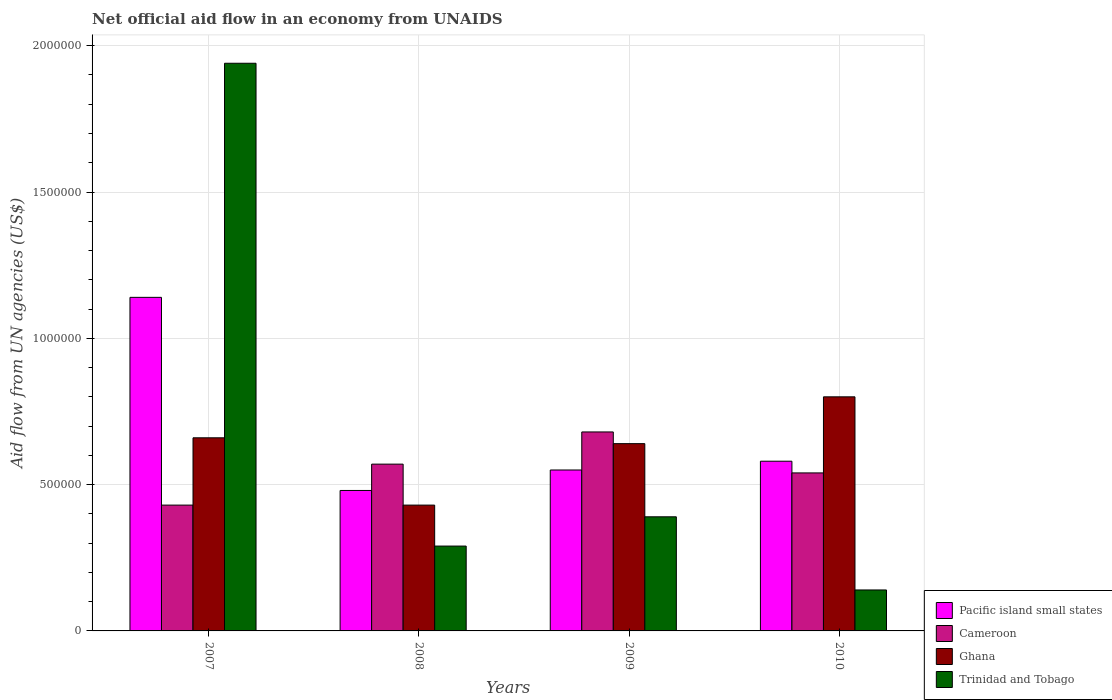How many groups of bars are there?
Your answer should be very brief. 4. Are the number of bars per tick equal to the number of legend labels?
Your response must be concise. Yes. What is the label of the 2nd group of bars from the left?
Provide a succinct answer. 2008. In how many cases, is the number of bars for a given year not equal to the number of legend labels?
Provide a short and direct response. 0. What is the net official aid flow in Ghana in 2007?
Your answer should be very brief. 6.60e+05. Across all years, what is the maximum net official aid flow in Pacific island small states?
Your answer should be very brief. 1.14e+06. Across all years, what is the minimum net official aid flow in Cameroon?
Offer a very short reply. 4.30e+05. In which year was the net official aid flow in Ghana minimum?
Your answer should be very brief. 2008. What is the total net official aid flow in Ghana in the graph?
Make the answer very short. 2.53e+06. What is the difference between the net official aid flow in Trinidad and Tobago in 2007 and that in 2009?
Offer a very short reply. 1.55e+06. What is the difference between the net official aid flow in Pacific island small states in 2007 and the net official aid flow in Trinidad and Tobago in 2009?
Give a very brief answer. 7.50e+05. What is the average net official aid flow in Cameroon per year?
Offer a terse response. 5.55e+05. In the year 2007, what is the difference between the net official aid flow in Cameroon and net official aid flow in Trinidad and Tobago?
Give a very brief answer. -1.51e+06. What is the ratio of the net official aid flow in Trinidad and Tobago in 2008 to that in 2010?
Make the answer very short. 2.07. Is the net official aid flow in Ghana in 2008 less than that in 2009?
Give a very brief answer. Yes. Is the difference between the net official aid flow in Cameroon in 2008 and 2010 greater than the difference between the net official aid flow in Trinidad and Tobago in 2008 and 2010?
Ensure brevity in your answer.  No. What is the difference between the highest and the second highest net official aid flow in Pacific island small states?
Make the answer very short. 5.60e+05. What is the difference between the highest and the lowest net official aid flow in Trinidad and Tobago?
Your answer should be compact. 1.80e+06. In how many years, is the net official aid flow in Pacific island small states greater than the average net official aid flow in Pacific island small states taken over all years?
Provide a succinct answer. 1. Is the sum of the net official aid flow in Pacific island small states in 2008 and 2010 greater than the maximum net official aid flow in Trinidad and Tobago across all years?
Offer a terse response. No. What does the 2nd bar from the left in 2007 represents?
Offer a terse response. Cameroon. What does the 4th bar from the right in 2010 represents?
Provide a short and direct response. Pacific island small states. Is it the case that in every year, the sum of the net official aid flow in Pacific island small states and net official aid flow in Ghana is greater than the net official aid flow in Cameroon?
Keep it short and to the point. Yes. Are all the bars in the graph horizontal?
Ensure brevity in your answer.  No. What is the difference between two consecutive major ticks on the Y-axis?
Your response must be concise. 5.00e+05. Where does the legend appear in the graph?
Offer a very short reply. Bottom right. How are the legend labels stacked?
Your response must be concise. Vertical. What is the title of the graph?
Provide a succinct answer. Net official aid flow in an economy from UNAIDS. What is the label or title of the X-axis?
Your response must be concise. Years. What is the label or title of the Y-axis?
Ensure brevity in your answer.  Aid flow from UN agencies (US$). What is the Aid flow from UN agencies (US$) of Pacific island small states in 2007?
Give a very brief answer. 1.14e+06. What is the Aid flow from UN agencies (US$) of Trinidad and Tobago in 2007?
Your answer should be compact. 1.94e+06. What is the Aid flow from UN agencies (US$) in Pacific island small states in 2008?
Offer a very short reply. 4.80e+05. What is the Aid flow from UN agencies (US$) in Cameroon in 2008?
Give a very brief answer. 5.70e+05. What is the Aid flow from UN agencies (US$) in Trinidad and Tobago in 2008?
Make the answer very short. 2.90e+05. What is the Aid flow from UN agencies (US$) in Pacific island small states in 2009?
Your response must be concise. 5.50e+05. What is the Aid flow from UN agencies (US$) of Cameroon in 2009?
Offer a terse response. 6.80e+05. What is the Aid flow from UN agencies (US$) of Ghana in 2009?
Provide a succinct answer. 6.40e+05. What is the Aid flow from UN agencies (US$) in Pacific island small states in 2010?
Make the answer very short. 5.80e+05. What is the Aid flow from UN agencies (US$) in Cameroon in 2010?
Provide a short and direct response. 5.40e+05. What is the Aid flow from UN agencies (US$) in Ghana in 2010?
Your response must be concise. 8.00e+05. What is the Aid flow from UN agencies (US$) in Trinidad and Tobago in 2010?
Ensure brevity in your answer.  1.40e+05. Across all years, what is the maximum Aid flow from UN agencies (US$) in Pacific island small states?
Give a very brief answer. 1.14e+06. Across all years, what is the maximum Aid flow from UN agencies (US$) of Cameroon?
Make the answer very short. 6.80e+05. Across all years, what is the maximum Aid flow from UN agencies (US$) in Ghana?
Ensure brevity in your answer.  8.00e+05. Across all years, what is the maximum Aid flow from UN agencies (US$) of Trinidad and Tobago?
Give a very brief answer. 1.94e+06. Across all years, what is the minimum Aid flow from UN agencies (US$) in Cameroon?
Offer a very short reply. 4.30e+05. What is the total Aid flow from UN agencies (US$) of Pacific island small states in the graph?
Provide a short and direct response. 2.75e+06. What is the total Aid flow from UN agencies (US$) in Cameroon in the graph?
Your answer should be compact. 2.22e+06. What is the total Aid flow from UN agencies (US$) in Ghana in the graph?
Your answer should be compact. 2.53e+06. What is the total Aid flow from UN agencies (US$) in Trinidad and Tobago in the graph?
Give a very brief answer. 2.76e+06. What is the difference between the Aid flow from UN agencies (US$) of Trinidad and Tobago in 2007 and that in 2008?
Offer a very short reply. 1.65e+06. What is the difference between the Aid flow from UN agencies (US$) in Pacific island small states in 2007 and that in 2009?
Offer a terse response. 5.90e+05. What is the difference between the Aid flow from UN agencies (US$) in Trinidad and Tobago in 2007 and that in 2009?
Your answer should be very brief. 1.55e+06. What is the difference between the Aid flow from UN agencies (US$) in Pacific island small states in 2007 and that in 2010?
Provide a succinct answer. 5.60e+05. What is the difference between the Aid flow from UN agencies (US$) in Trinidad and Tobago in 2007 and that in 2010?
Offer a terse response. 1.80e+06. What is the difference between the Aid flow from UN agencies (US$) in Pacific island small states in 2008 and that in 2009?
Your answer should be compact. -7.00e+04. What is the difference between the Aid flow from UN agencies (US$) of Ghana in 2008 and that in 2009?
Give a very brief answer. -2.10e+05. What is the difference between the Aid flow from UN agencies (US$) of Pacific island small states in 2008 and that in 2010?
Your answer should be very brief. -1.00e+05. What is the difference between the Aid flow from UN agencies (US$) of Ghana in 2008 and that in 2010?
Provide a succinct answer. -3.70e+05. What is the difference between the Aid flow from UN agencies (US$) of Trinidad and Tobago in 2008 and that in 2010?
Provide a short and direct response. 1.50e+05. What is the difference between the Aid flow from UN agencies (US$) in Pacific island small states in 2009 and that in 2010?
Give a very brief answer. -3.00e+04. What is the difference between the Aid flow from UN agencies (US$) in Cameroon in 2009 and that in 2010?
Provide a succinct answer. 1.40e+05. What is the difference between the Aid flow from UN agencies (US$) of Pacific island small states in 2007 and the Aid flow from UN agencies (US$) of Cameroon in 2008?
Provide a short and direct response. 5.70e+05. What is the difference between the Aid flow from UN agencies (US$) of Pacific island small states in 2007 and the Aid flow from UN agencies (US$) of Ghana in 2008?
Provide a succinct answer. 7.10e+05. What is the difference between the Aid flow from UN agencies (US$) in Pacific island small states in 2007 and the Aid flow from UN agencies (US$) in Trinidad and Tobago in 2008?
Your response must be concise. 8.50e+05. What is the difference between the Aid flow from UN agencies (US$) of Cameroon in 2007 and the Aid flow from UN agencies (US$) of Ghana in 2008?
Provide a succinct answer. 0. What is the difference between the Aid flow from UN agencies (US$) of Cameroon in 2007 and the Aid flow from UN agencies (US$) of Trinidad and Tobago in 2008?
Make the answer very short. 1.40e+05. What is the difference between the Aid flow from UN agencies (US$) in Ghana in 2007 and the Aid flow from UN agencies (US$) in Trinidad and Tobago in 2008?
Your answer should be very brief. 3.70e+05. What is the difference between the Aid flow from UN agencies (US$) in Pacific island small states in 2007 and the Aid flow from UN agencies (US$) in Cameroon in 2009?
Your response must be concise. 4.60e+05. What is the difference between the Aid flow from UN agencies (US$) of Pacific island small states in 2007 and the Aid flow from UN agencies (US$) of Ghana in 2009?
Your response must be concise. 5.00e+05. What is the difference between the Aid flow from UN agencies (US$) in Pacific island small states in 2007 and the Aid flow from UN agencies (US$) in Trinidad and Tobago in 2009?
Offer a very short reply. 7.50e+05. What is the difference between the Aid flow from UN agencies (US$) of Cameroon in 2007 and the Aid flow from UN agencies (US$) of Ghana in 2009?
Make the answer very short. -2.10e+05. What is the difference between the Aid flow from UN agencies (US$) in Ghana in 2007 and the Aid flow from UN agencies (US$) in Trinidad and Tobago in 2009?
Offer a very short reply. 2.70e+05. What is the difference between the Aid flow from UN agencies (US$) of Pacific island small states in 2007 and the Aid flow from UN agencies (US$) of Trinidad and Tobago in 2010?
Your answer should be very brief. 1.00e+06. What is the difference between the Aid flow from UN agencies (US$) in Cameroon in 2007 and the Aid flow from UN agencies (US$) in Ghana in 2010?
Your response must be concise. -3.70e+05. What is the difference between the Aid flow from UN agencies (US$) in Cameroon in 2007 and the Aid flow from UN agencies (US$) in Trinidad and Tobago in 2010?
Keep it short and to the point. 2.90e+05. What is the difference between the Aid flow from UN agencies (US$) of Ghana in 2007 and the Aid flow from UN agencies (US$) of Trinidad and Tobago in 2010?
Provide a short and direct response. 5.20e+05. What is the difference between the Aid flow from UN agencies (US$) of Pacific island small states in 2008 and the Aid flow from UN agencies (US$) of Cameroon in 2009?
Give a very brief answer. -2.00e+05. What is the difference between the Aid flow from UN agencies (US$) in Pacific island small states in 2008 and the Aid flow from UN agencies (US$) in Ghana in 2009?
Your response must be concise. -1.60e+05. What is the difference between the Aid flow from UN agencies (US$) in Pacific island small states in 2008 and the Aid flow from UN agencies (US$) in Ghana in 2010?
Offer a terse response. -3.20e+05. What is the difference between the Aid flow from UN agencies (US$) in Pacific island small states in 2009 and the Aid flow from UN agencies (US$) in Ghana in 2010?
Give a very brief answer. -2.50e+05. What is the difference between the Aid flow from UN agencies (US$) of Cameroon in 2009 and the Aid flow from UN agencies (US$) of Ghana in 2010?
Offer a terse response. -1.20e+05. What is the difference between the Aid flow from UN agencies (US$) of Cameroon in 2009 and the Aid flow from UN agencies (US$) of Trinidad and Tobago in 2010?
Make the answer very short. 5.40e+05. What is the average Aid flow from UN agencies (US$) of Pacific island small states per year?
Your response must be concise. 6.88e+05. What is the average Aid flow from UN agencies (US$) of Cameroon per year?
Offer a very short reply. 5.55e+05. What is the average Aid flow from UN agencies (US$) in Ghana per year?
Provide a succinct answer. 6.32e+05. What is the average Aid flow from UN agencies (US$) in Trinidad and Tobago per year?
Give a very brief answer. 6.90e+05. In the year 2007, what is the difference between the Aid flow from UN agencies (US$) in Pacific island small states and Aid flow from UN agencies (US$) in Cameroon?
Provide a short and direct response. 7.10e+05. In the year 2007, what is the difference between the Aid flow from UN agencies (US$) in Pacific island small states and Aid flow from UN agencies (US$) in Trinidad and Tobago?
Give a very brief answer. -8.00e+05. In the year 2007, what is the difference between the Aid flow from UN agencies (US$) of Cameroon and Aid flow from UN agencies (US$) of Trinidad and Tobago?
Make the answer very short. -1.51e+06. In the year 2007, what is the difference between the Aid flow from UN agencies (US$) of Ghana and Aid flow from UN agencies (US$) of Trinidad and Tobago?
Provide a short and direct response. -1.28e+06. In the year 2008, what is the difference between the Aid flow from UN agencies (US$) in Cameroon and Aid flow from UN agencies (US$) in Ghana?
Provide a short and direct response. 1.40e+05. In the year 2008, what is the difference between the Aid flow from UN agencies (US$) of Cameroon and Aid flow from UN agencies (US$) of Trinidad and Tobago?
Ensure brevity in your answer.  2.80e+05. In the year 2009, what is the difference between the Aid flow from UN agencies (US$) of Pacific island small states and Aid flow from UN agencies (US$) of Ghana?
Offer a very short reply. -9.00e+04. In the year 2009, what is the difference between the Aid flow from UN agencies (US$) in Pacific island small states and Aid flow from UN agencies (US$) in Trinidad and Tobago?
Provide a succinct answer. 1.60e+05. In the year 2009, what is the difference between the Aid flow from UN agencies (US$) of Cameroon and Aid flow from UN agencies (US$) of Ghana?
Your response must be concise. 4.00e+04. In the year 2009, what is the difference between the Aid flow from UN agencies (US$) in Cameroon and Aid flow from UN agencies (US$) in Trinidad and Tobago?
Offer a terse response. 2.90e+05. In the year 2010, what is the difference between the Aid flow from UN agencies (US$) in Pacific island small states and Aid flow from UN agencies (US$) in Cameroon?
Ensure brevity in your answer.  4.00e+04. In the year 2010, what is the difference between the Aid flow from UN agencies (US$) of Cameroon and Aid flow from UN agencies (US$) of Trinidad and Tobago?
Keep it short and to the point. 4.00e+05. What is the ratio of the Aid flow from UN agencies (US$) of Pacific island small states in 2007 to that in 2008?
Give a very brief answer. 2.38. What is the ratio of the Aid flow from UN agencies (US$) in Cameroon in 2007 to that in 2008?
Your response must be concise. 0.75. What is the ratio of the Aid flow from UN agencies (US$) of Ghana in 2007 to that in 2008?
Offer a terse response. 1.53. What is the ratio of the Aid flow from UN agencies (US$) in Trinidad and Tobago in 2007 to that in 2008?
Give a very brief answer. 6.69. What is the ratio of the Aid flow from UN agencies (US$) in Pacific island small states in 2007 to that in 2009?
Provide a short and direct response. 2.07. What is the ratio of the Aid flow from UN agencies (US$) in Cameroon in 2007 to that in 2009?
Your response must be concise. 0.63. What is the ratio of the Aid flow from UN agencies (US$) of Ghana in 2007 to that in 2009?
Offer a very short reply. 1.03. What is the ratio of the Aid flow from UN agencies (US$) in Trinidad and Tobago in 2007 to that in 2009?
Offer a terse response. 4.97. What is the ratio of the Aid flow from UN agencies (US$) in Pacific island small states in 2007 to that in 2010?
Make the answer very short. 1.97. What is the ratio of the Aid flow from UN agencies (US$) in Cameroon in 2007 to that in 2010?
Provide a short and direct response. 0.8. What is the ratio of the Aid flow from UN agencies (US$) of Ghana in 2007 to that in 2010?
Your answer should be compact. 0.82. What is the ratio of the Aid flow from UN agencies (US$) of Trinidad and Tobago in 2007 to that in 2010?
Make the answer very short. 13.86. What is the ratio of the Aid flow from UN agencies (US$) in Pacific island small states in 2008 to that in 2009?
Ensure brevity in your answer.  0.87. What is the ratio of the Aid flow from UN agencies (US$) of Cameroon in 2008 to that in 2009?
Your answer should be very brief. 0.84. What is the ratio of the Aid flow from UN agencies (US$) in Ghana in 2008 to that in 2009?
Your response must be concise. 0.67. What is the ratio of the Aid flow from UN agencies (US$) in Trinidad and Tobago in 2008 to that in 2009?
Ensure brevity in your answer.  0.74. What is the ratio of the Aid flow from UN agencies (US$) in Pacific island small states in 2008 to that in 2010?
Provide a short and direct response. 0.83. What is the ratio of the Aid flow from UN agencies (US$) in Cameroon in 2008 to that in 2010?
Your answer should be very brief. 1.06. What is the ratio of the Aid flow from UN agencies (US$) of Ghana in 2008 to that in 2010?
Make the answer very short. 0.54. What is the ratio of the Aid flow from UN agencies (US$) in Trinidad and Tobago in 2008 to that in 2010?
Offer a very short reply. 2.07. What is the ratio of the Aid flow from UN agencies (US$) of Pacific island small states in 2009 to that in 2010?
Keep it short and to the point. 0.95. What is the ratio of the Aid flow from UN agencies (US$) in Cameroon in 2009 to that in 2010?
Ensure brevity in your answer.  1.26. What is the ratio of the Aid flow from UN agencies (US$) in Trinidad and Tobago in 2009 to that in 2010?
Offer a very short reply. 2.79. What is the difference between the highest and the second highest Aid flow from UN agencies (US$) in Pacific island small states?
Your answer should be very brief. 5.60e+05. What is the difference between the highest and the second highest Aid flow from UN agencies (US$) in Cameroon?
Give a very brief answer. 1.10e+05. What is the difference between the highest and the second highest Aid flow from UN agencies (US$) in Trinidad and Tobago?
Your answer should be very brief. 1.55e+06. What is the difference between the highest and the lowest Aid flow from UN agencies (US$) in Trinidad and Tobago?
Your response must be concise. 1.80e+06. 